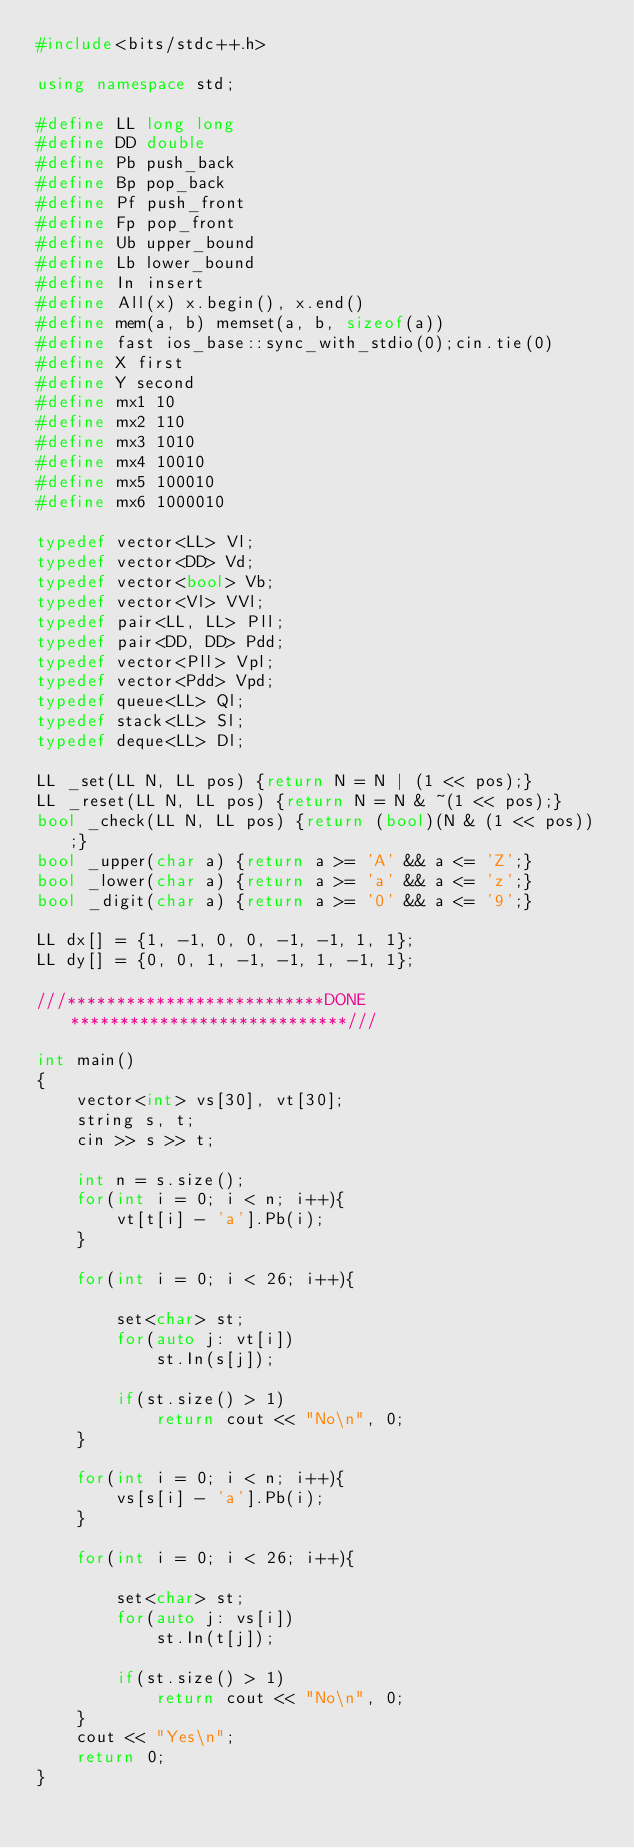Convert code to text. <code><loc_0><loc_0><loc_500><loc_500><_C++_>#include<bits/stdc++.h>

using namespace std;

#define LL long long
#define DD double
#define Pb push_back
#define Bp pop_back
#define Pf push_front
#define Fp pop_front
#define Ub upper_bound
#define Lb lower_bound
#define In insert
#define All(x) x.begin(), x.end()
#define mem(a, b) memset(a, b, sizeof(a))
#define fast ios_base::sync_with_stdio(0);cin.tie(0)
#define X first
#define Y second
#define mx1 10
#define mx2 110
#define mx3 1010
#define mx4 10010
#define mx5 100010
#define mx6 1000010

typedef vector<LL> Vl;
typedef vector<DD> Vd;
typedef vector<bool> Vb;
typedef vector<Vl> VVl;
typedef pair<LL, LL> Pll;
typedef pair<DD, DD> Pdd;
typedef vector<Pll> Vpl;
typedef vector<Pdd> Vpd;
typedef queue<LL> Ql;
typedef stack<LL> Sl;
typedef deque<LL> Dl;

LL _set(LL N, LL pos) {return N = N | (1 << pos);}
LL _reset(LL N, LL pos) {return N = N & ~(1 << pos);}
bool _check(LL N, LL pos) {return (bool)(N & (1 << pos));}
bool _upper(char a) {return a >= 'A' && a <= 'Z';}
bool _lower(char a) {return a >= 'a' && a <= 'z';}
bool _digit(char a) {return a >= '0' && a <= '9';}

LL dx[] = {1, -1, 0, 0, -1, -1, 1, 1};
LL dy[] = {0, 0, 1, -1, -1, 1, -1, 1};

///**************************DONE****************************///

int main()
{
    vector<int> vs[30], vt[30];
    string s, t;
    cin >> s >> t;

    int n = s.size();
    for(int i = 0; i < n; i++){
        vt[t[i] - 'a'].Pb(i);
    }

    for(int i = 0; i < 26; i++){

        set<char> st;
        for(auto j: vt[i])
            st.In(s[j]);

        if(st.size() > 1)
            return cout << "No\n", 0;
    }

    for(int i = 0; i < n; i++){
        vs[s[i] - 'a'].Pb(i);
    }

    for(int i = 0; i < 26; i++){

        set<char> st;
        for(auto j: vs[i])
            st.In(t[j]);

        if(st.size() > 1)
            return cout << "No\n", 0;
    }
    cout << "Yes\n";
    return 0;
}
</code> 